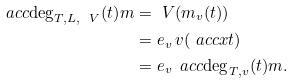Convert formula to latex. <formula><loc_0><loc_0><loc_500><loc_500>\ a c c { \deg _ { T , L , \ V } ( t ) } { m } & = \ V ( m _ { v } ( t ) ) \\ & = e _ { v } \, v ( \ a c c { x } { t } ) \\ & = e _ { v } \, \ a c c { \deg _ { T , v } ( t ) } { m } .</formula> 